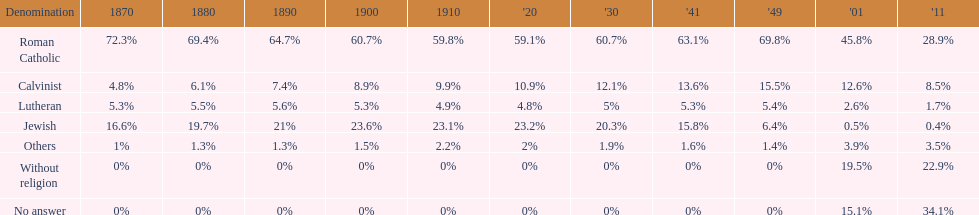How many denominations never dropped below 20%? 1. 